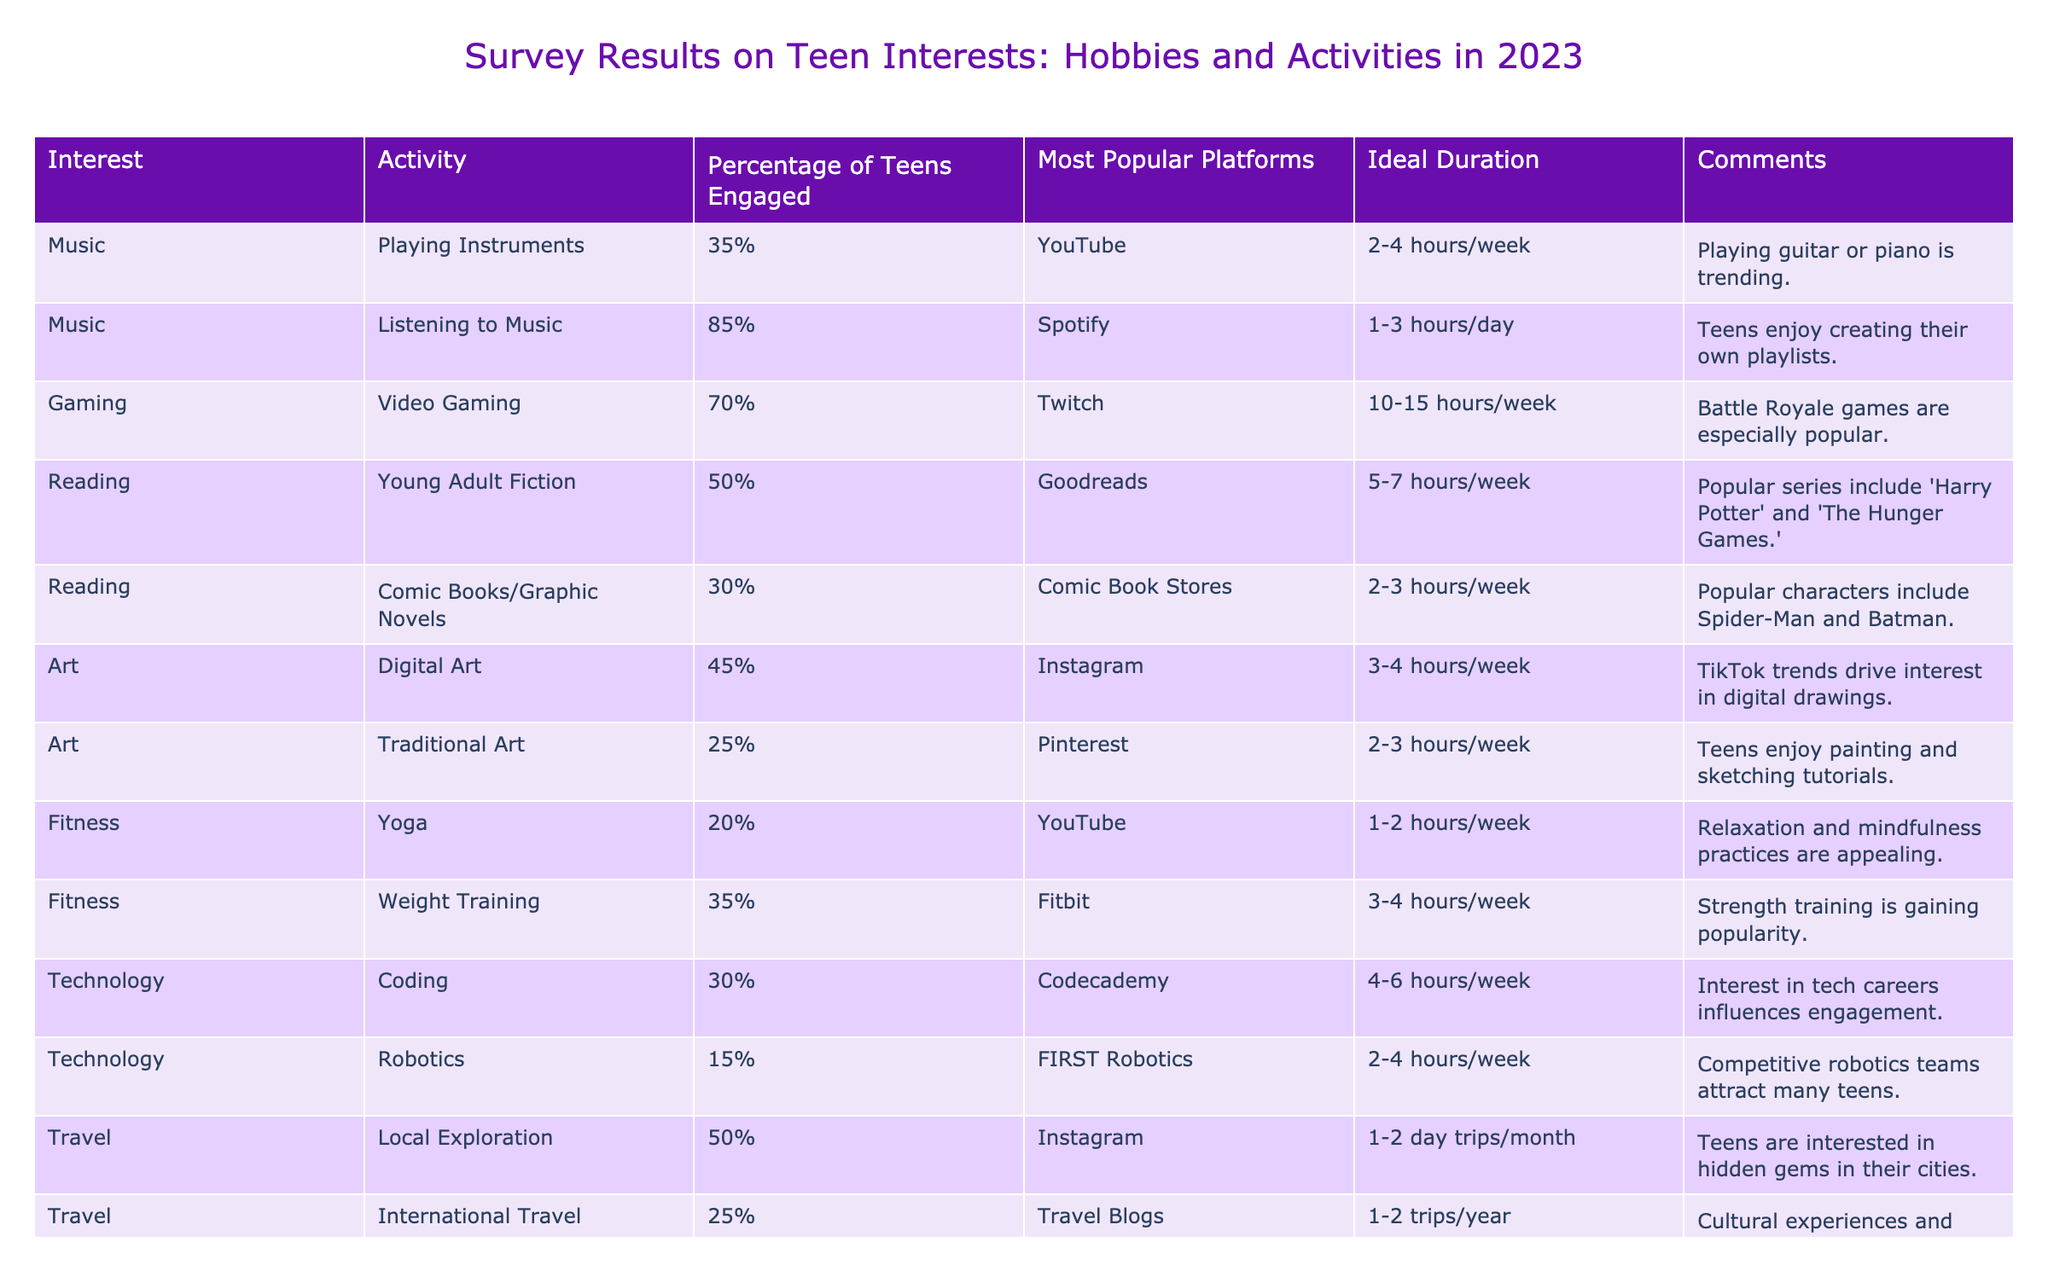What percentage of teens are engaged in listening to music? The table indicates that 85% of teens are engaged in listening to music, which is directly listed under the 'Percentage of Teens Engaged' column for the music category.
Answer: 85% Which hobby has the highest percentage of teen engagement? Upon reviewing the table, listening to music has the highest engagement at 85%, as compared to other activities listed.
Answer: Listening to music What is the ideal duration for teens to play instruments? The table shows that the ideal duration for playing instruments is 2-4 hours a week, specifically noted in the 'Ideal Duration' column for that activity.
Answer: 2-4 hours/week How many total hobbies have more than 50% engagement? Looking through the percentages, there are three hobbies (listening to music, video gaming, and staying connected with friends) that have more than 50% engagement.
Answer: Three Is the interest in robotics higher than yoga among teens? By comparing the percentages, robotics has 15% engagement while yoga has 20%, indicating that more teens are engaged in yoga than robotics.
Answer: No What is the average engagement percentage for the fitness category? Fitness includes two activities: yoga (20%) and weight training (35%). The average engagement is calculated by (20 + 35) / 2 = 27.5%.
Answer: 27.5% Which platform is the most popular for content creation and what is the engagement percentage? Content creation is associated with YouTube, and the table shows that 45% of teens are engaged in that area, making YouTube the most popular platform for this activity.
Answer: YouTube, 45% How does the engagement in local exploration compare to international travel? Local exploration has a 50% engagement rate while international travel has a 25% engagement rate, indicating local exploration is more popular among teens.
Answer: Local exploration is higher What is the difference in percentage engagement between digital art and traditional art? Digital art has a 45% engagement rate while traditional art has 25%. The difference is calculated as 45% - 25% = 20%.
Answer: 20% Are there more teens engaged in playing instruments than traditional art? Playing instruments has a 35% engagement, while traditional art has a 25% engagement, which means more teens are engaged in playing instruments.
Answer: Yes 